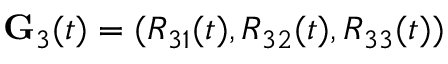<formula> <loc_0><loc_0><loc_500><loc_500>{ G } _ { 3 } ( t ) = ( R _ { 3 1 } ( t ) , R _ { 3 2 } ( t ) , R _ { 3 3 } ( t ) )</formula> 